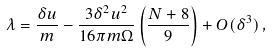Convert formula to latex. <formula><loc_0><loc_0><loc_500><loc_500>\lambda = \frac { \delta u } { m } - \frac { 3 \delta ^ { 2 } u ^ { 2 } } { 1 6 \pi m \Omega } \left ( \frac { N + 8 } { 9 } \right ) + O ( \delta ^ { 3 } ) \, ,</formula> 